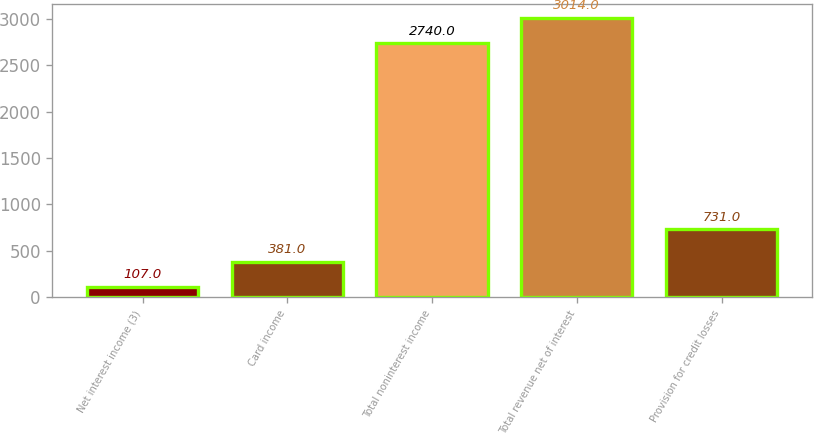Convert chart. <chart><loc_0><loc_0><loc_500><loc_500><bar_chart><fcel>Net interest income (3)<fcel>Card income<fcel>Total noninterest income<fcel>Total revenue net of interest<fcel>Provision for credit losses<nl><fcel>107<fcel>381<fcel>2740<fcel>3014<fcel>731<nl></chart> 